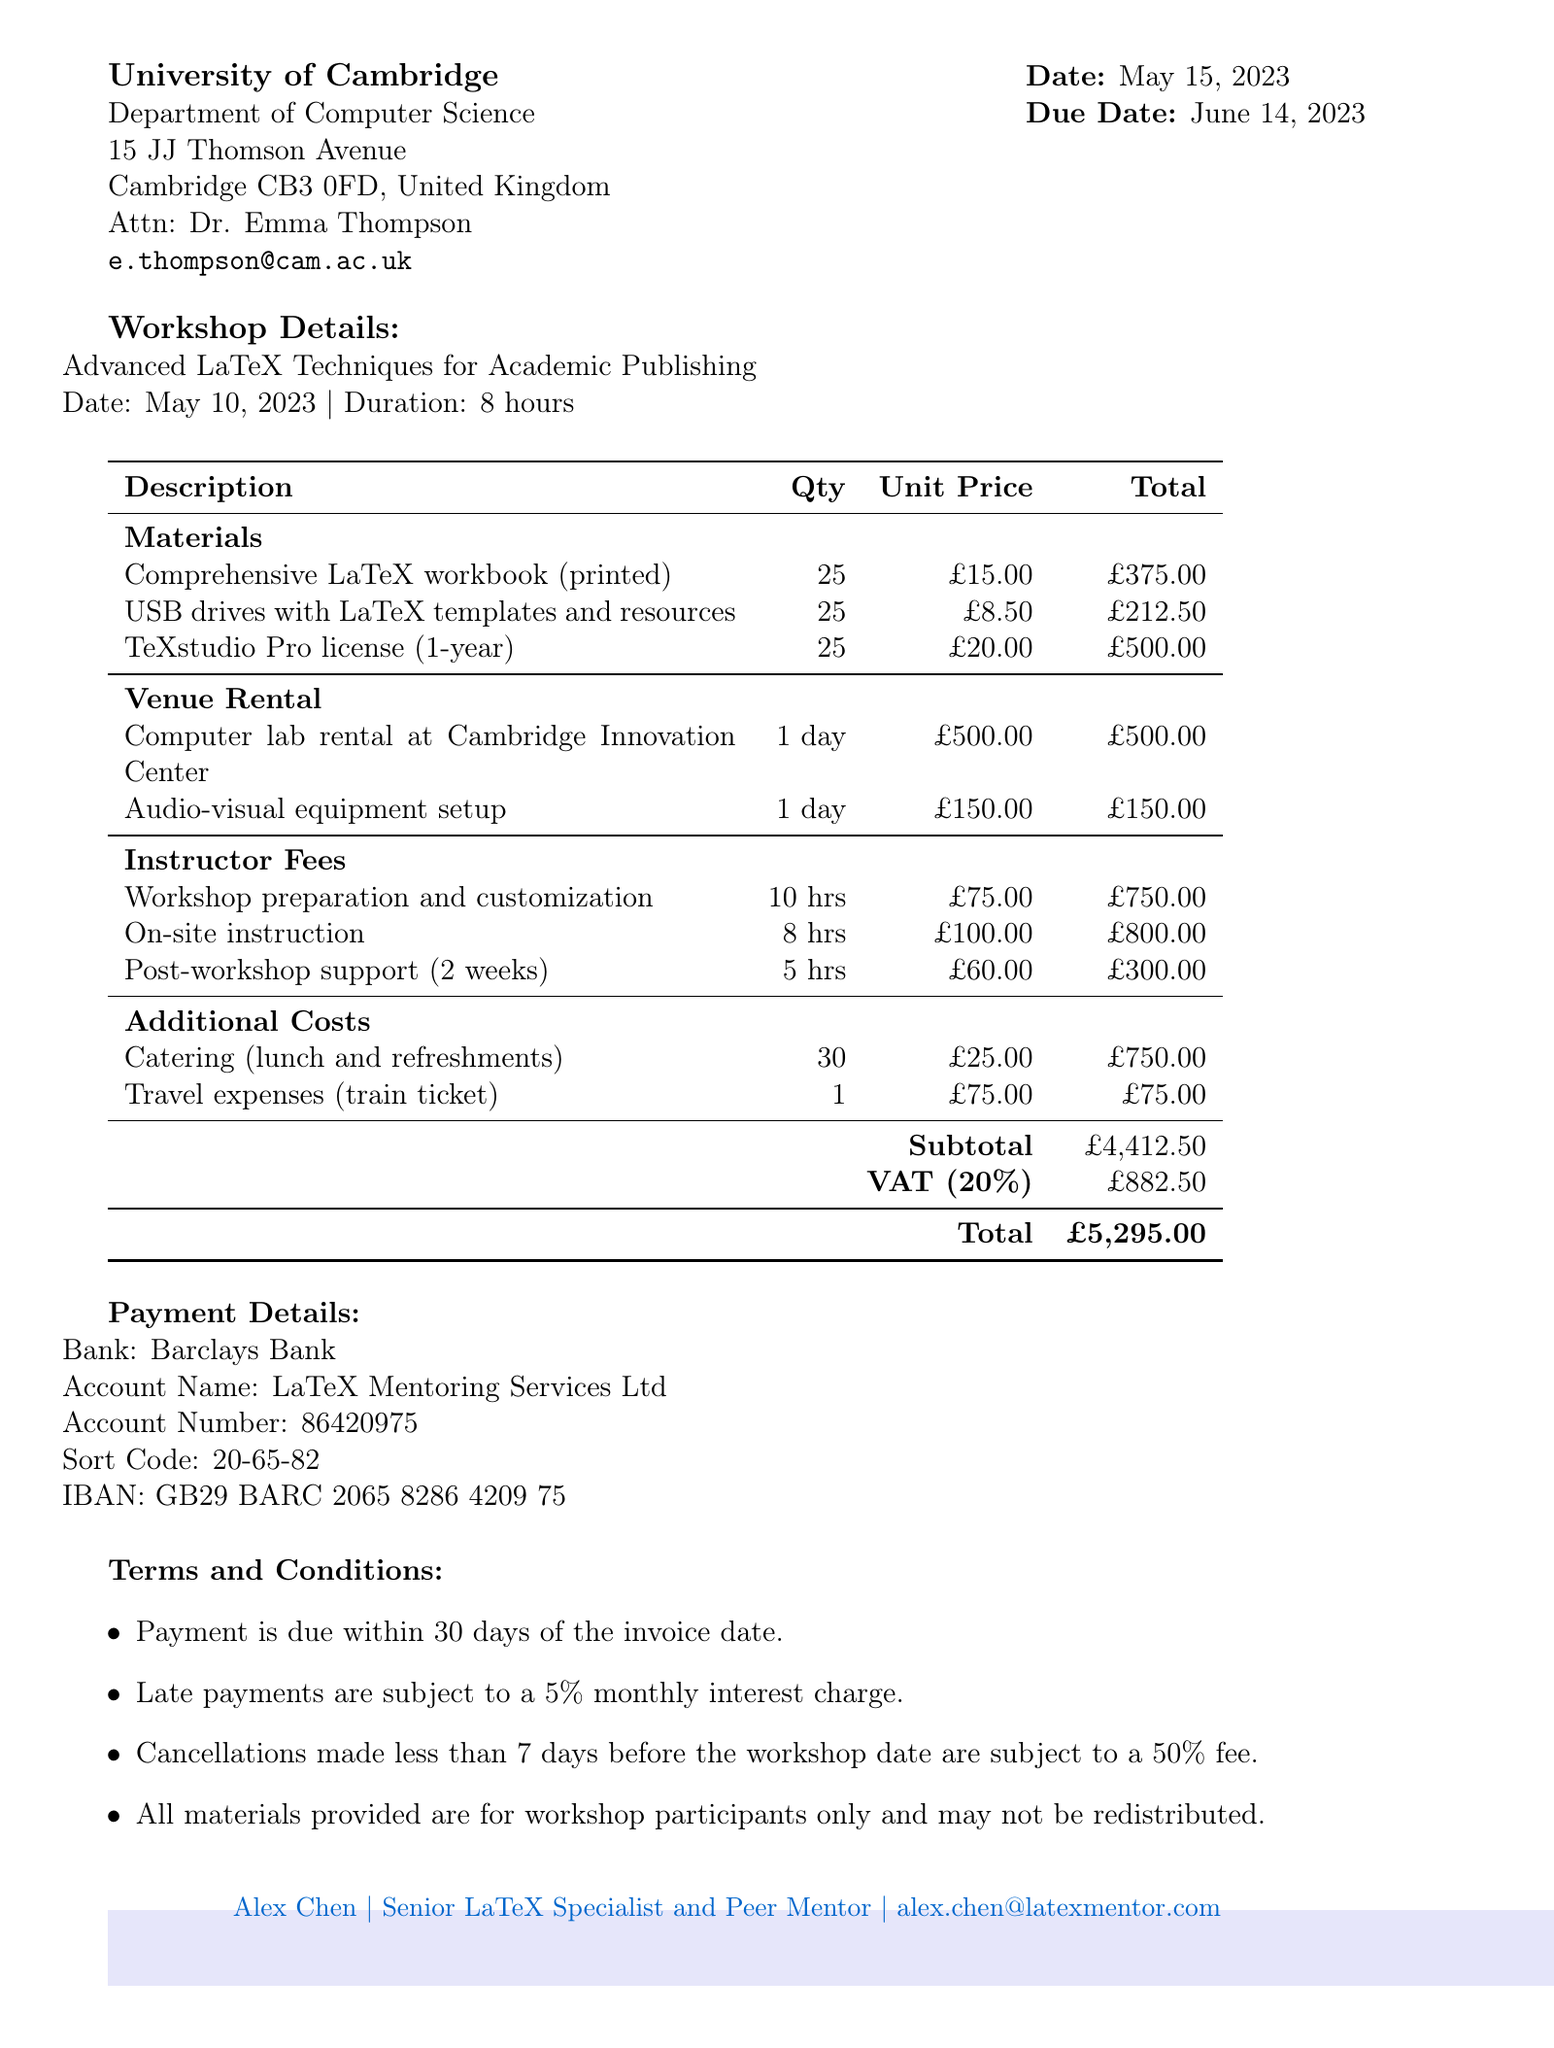What is the invoice number? The invoice number is specified in the document for reference.
Answer: LTX-2023-042 Who is the contact person for the client? The contact person is listed in the client information section.
Answer: Dr. Emma Thompson What is the total cost of the workshop? The total cost is the final amount due at the bottom of the invoice.
Answer: £5,295.00 How many hours was the on-site instruction? The number of hours for on-site instruction is mentioned in the instructor fees section.
Answer: 8 hours What is the unit price of the USB drives? The unit price for the USB drives is specified in the materials section of the invoice.
Answer: £8.50 What is the duration of the venue rental? The document states the rental duration in the venue rental section.
Answer: 1 day What percentage is the VAT in this invoice? The VAT percentage is mentioned in the total cost calculation section of the invoice.
Answer: 20% What is the total amount for catering? The total catering cost is provided in the itemized costs section of the invoice.
Answer: £750.00 What are the payment terms regarding late payments? The payment terms detail the conditions surrounding late payments specifically.
Answer: 5% monthly interest charge 